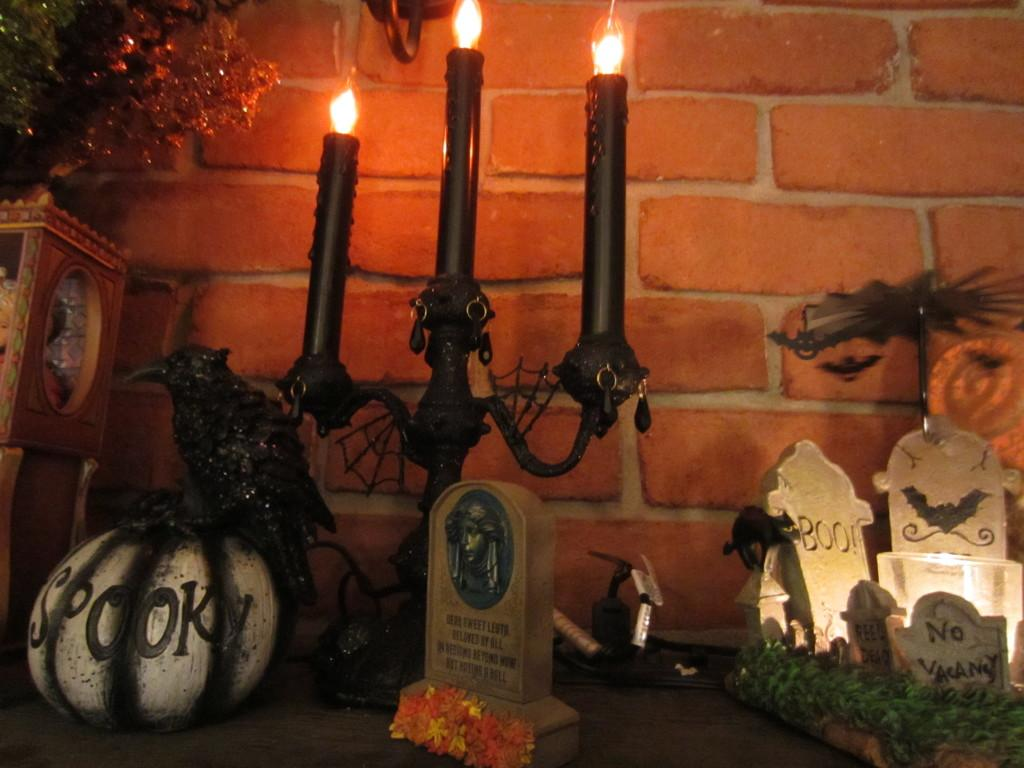What objects are in the center of the image? There are three candles in the center of the image. What other items can be seen in the image? There are toys, a pumpkin, flowers, plants, and some boxes in the image. What is the background of the image? There is a wall in the background of the image. What type of vegetation is present in the image? There are flowers and plants in the image. Can you tell me how many tomatoes are in the image? There are no tomatoes present in the image. What type of bag is being used to carry the toys in the image? There is no bag visible in the image; the toys are not being carried. 